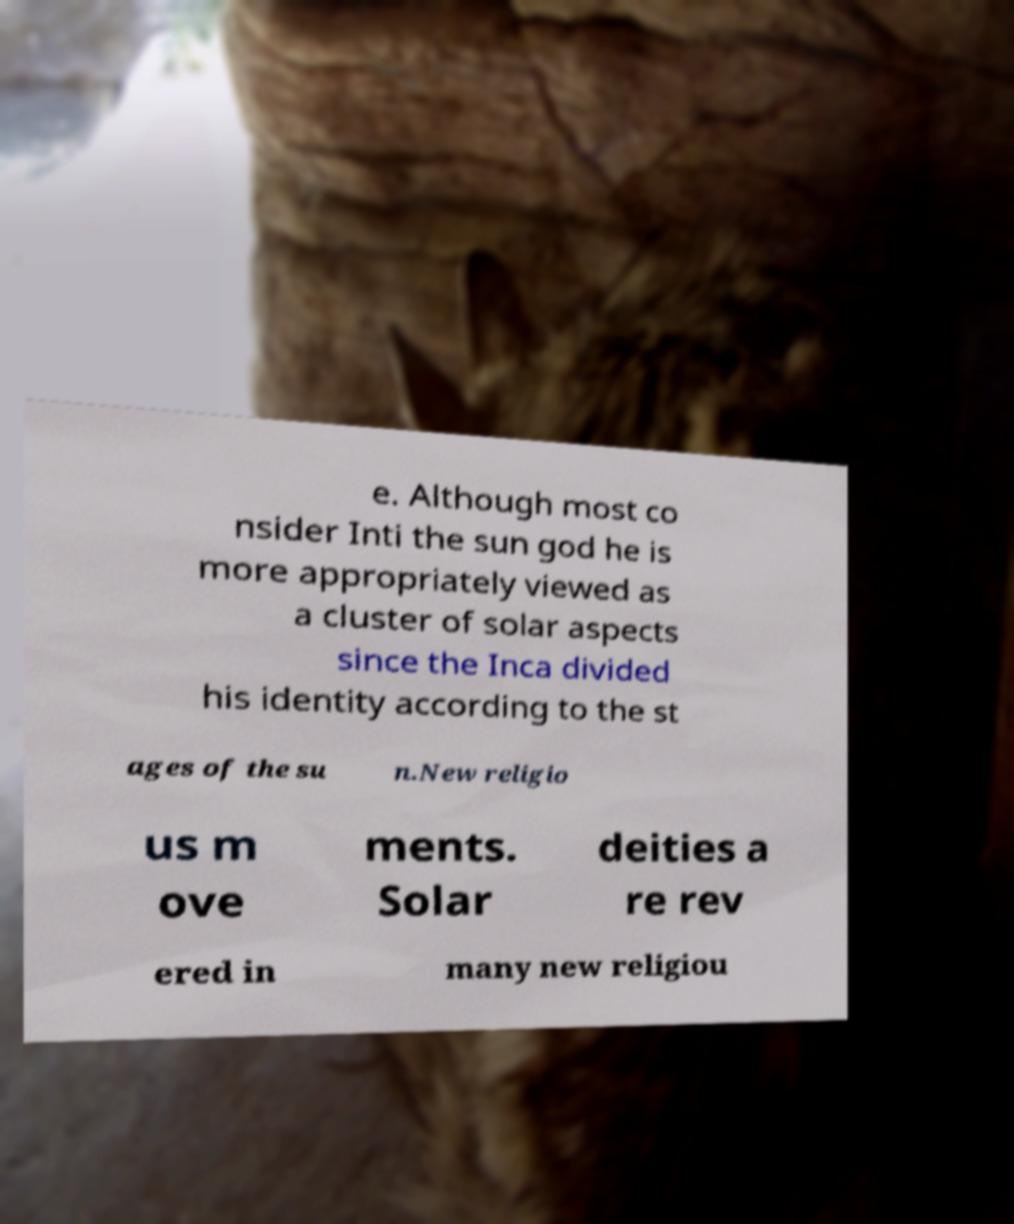Could you assist in decoding the text presented in this image and type it out clearly? e. Although most co nsider Inti the sun god he is more appropriately viewed as a cluster of solar aspects since the Inca divided his identity according to the st ages of the su n.New religio us m ove ments. Solar deities a re rev ered in many new religiou 